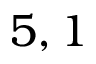Convert formula to latex. <formula><loc_0><loc_0><loc_500><loc_500>5 , 1</formula> 